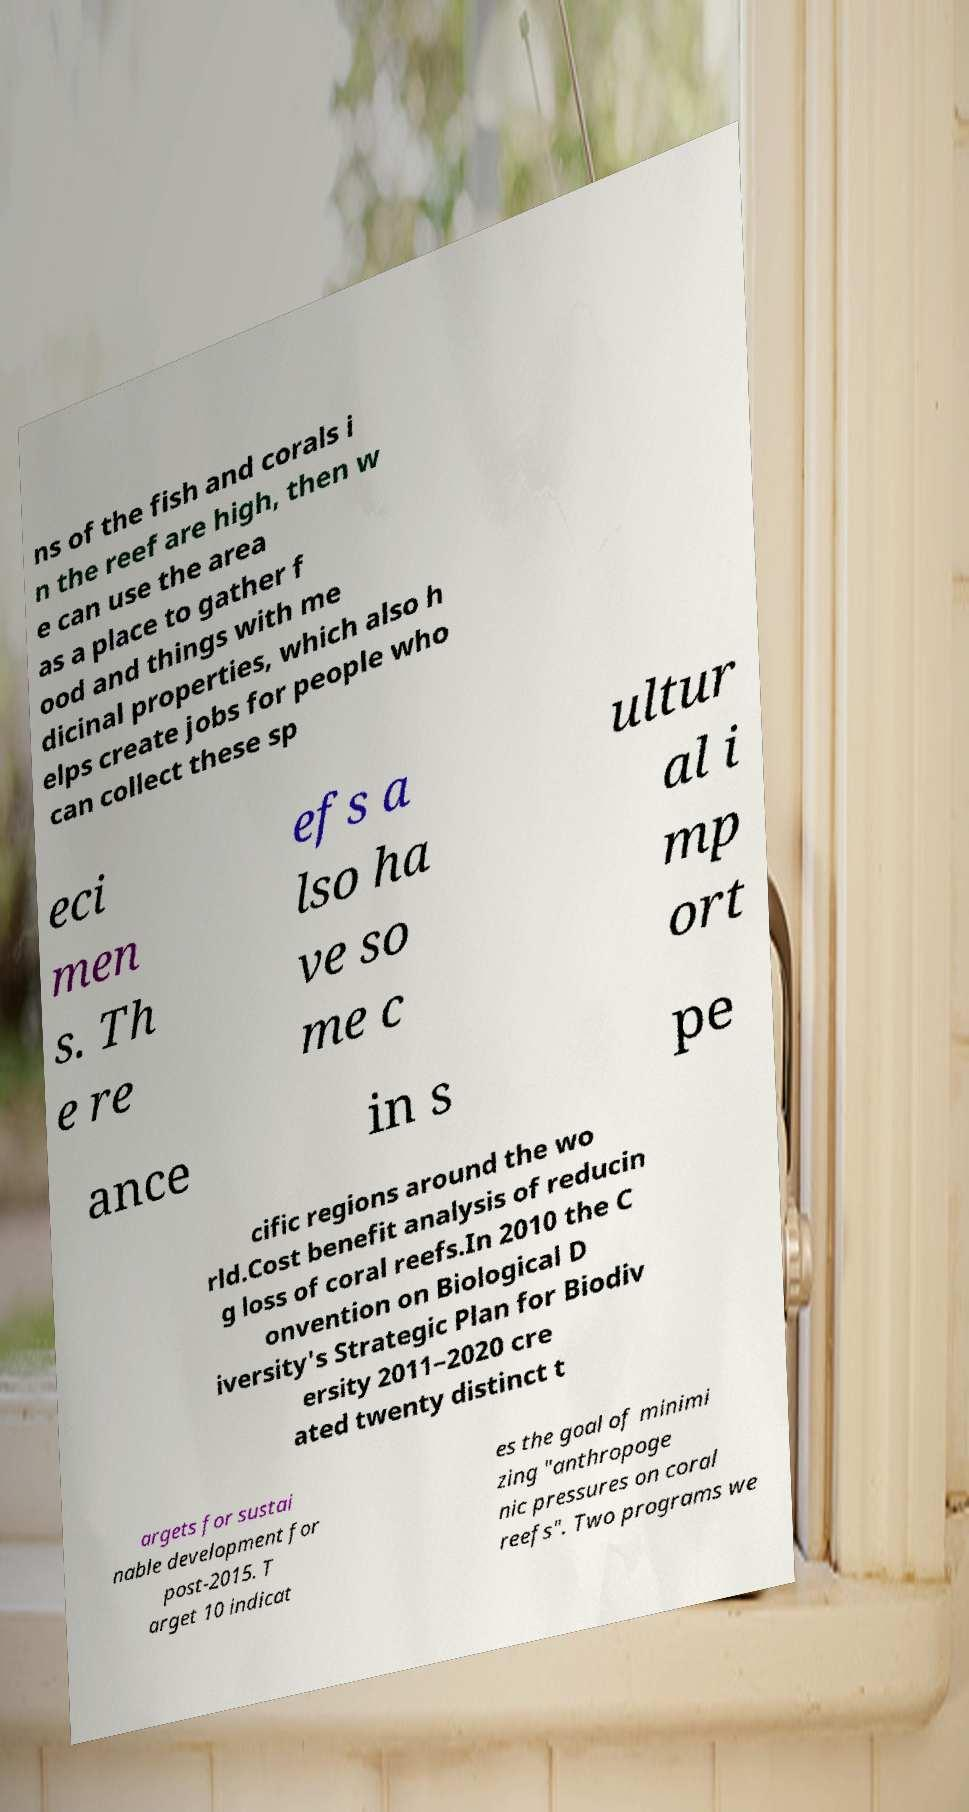Please read and relay the text visible in this image. What does it say? ns of the fish and corals i n the reef are high, then w e can use the area as a place to gather f ood and things with me dicinal properties, which also h elps create jobs for people who can collect these sp eci men s. Th e re efs a lso ha ve so me c ultur al i mp ort ance in s pe cific regions around the wo rld.Cost benefit analysis of reducin g loss of coral reefs.In 2010 the C onvention on Biological D iversity's Strategic Plan for Biodiv ersity 2011–2020 cre ated twenty distinct t argets for sustai nable development for post-2015. T arget 10 indicat es the goal of minimi zing "anthropoge nic pressures on coral reefs". Two programs we 